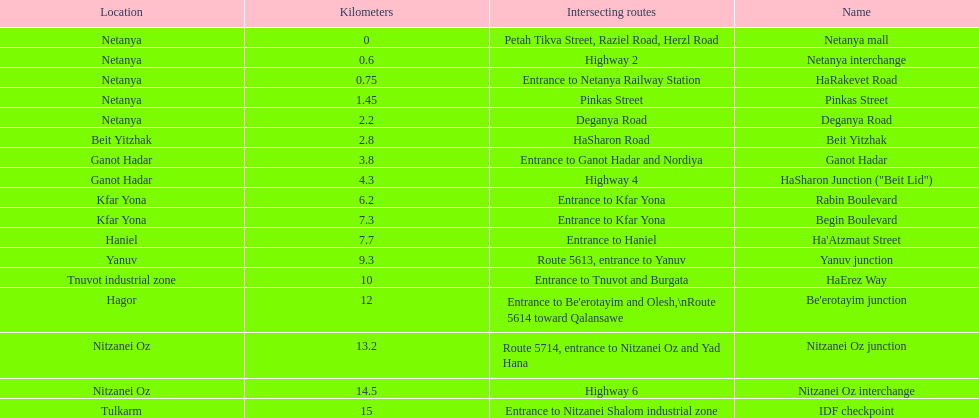How many sections intersect highway 2? 1. 